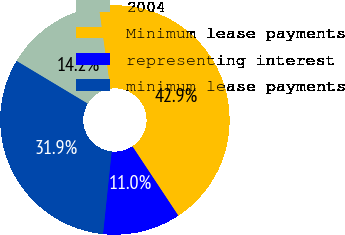Convert chart to OTSL. <chart><loc_0><loc_0><loc_500><loc_500><pie_chart><fcel>2004<fcel>Minimum lease payments<fcel>representing interest<fcel>minimum lease payments<nl><fcel>14.17%<fcel>42.92%<fcel>10.97%<fcel>31.94%<nl></chart> 